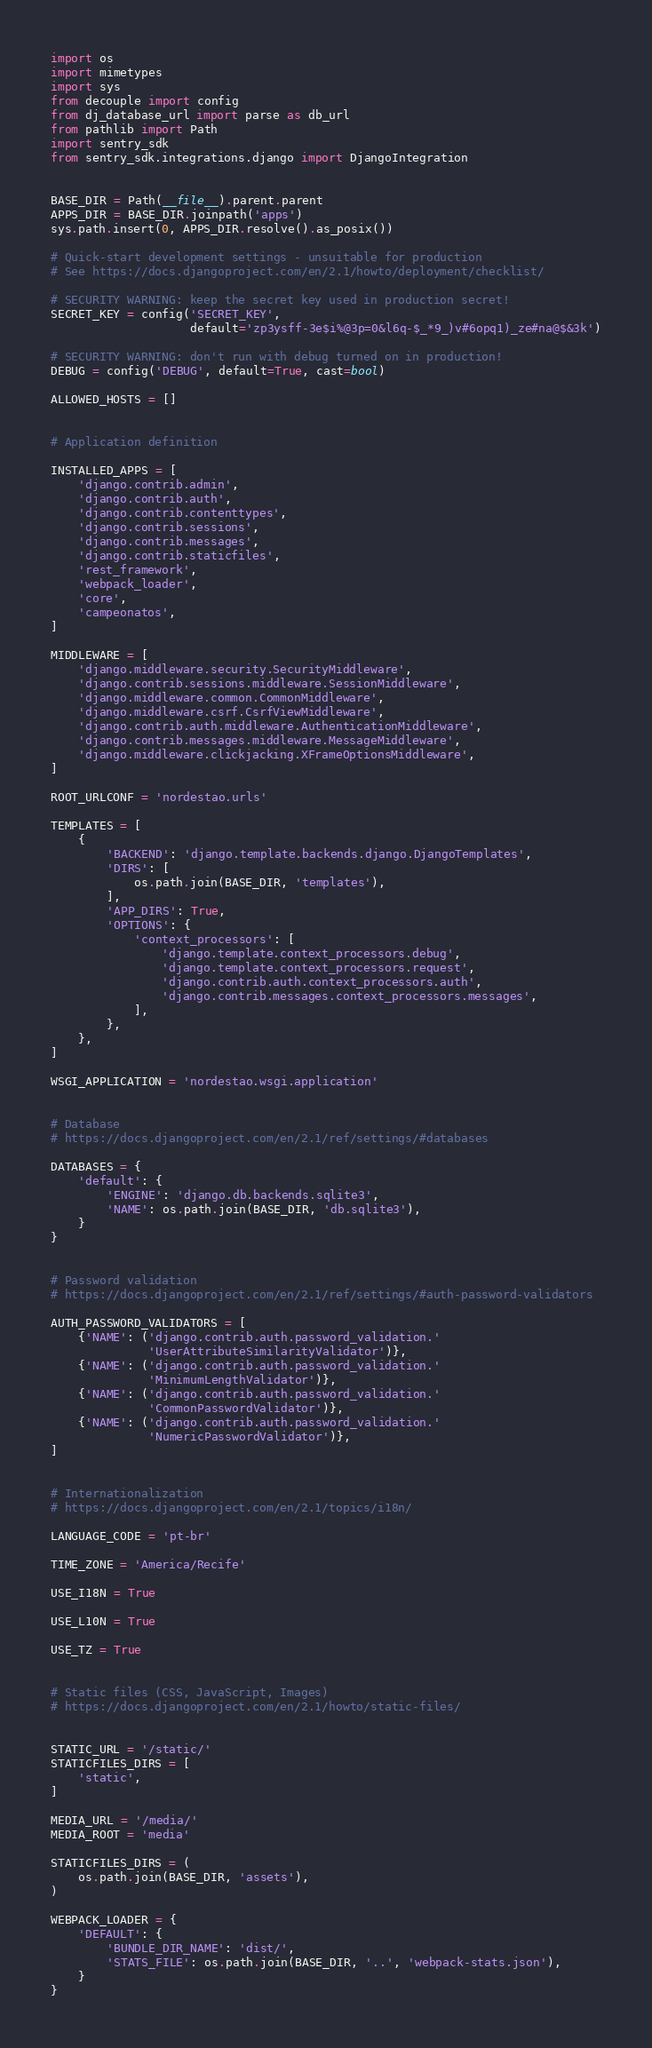<code> <loc_0><loc_0><loc_500><loc_500><_Python_>import os
import mimetypes
import sys
from decouple import config
from dj_database_url import parse as db_url
from pathlib import Path
import sentry_sdk
from sentry_sdk.integrations.django import DjangoIntegration


BASE_DIR = Path(__file__).parent.parent
APPS_DIR = BASE_DIR.joinpath('apps')
sys.path.insert(0, APPS_DIR.resolve().as_posix())

# Quick-start development settings - unsuitable for production
# See https://docs.djangoproject.com/en/2.1/howto/deployment/checklist/

# SECURITY WARNING: keep the secret key used in production secret!
SECRET_KEY = config('SECRET_KEY',
                    default='zp3ysff-3e$i%@3p=0&l6q-$_*9_)v#6opq1)_ze#na@$&3k')

# SECURITY WARNING: don't run with debug turned on in production!
DEBUG = config('DEBUG', default=True, cast=bool)

ALLOWED_HOSTS = []


# Application definition

INSTALLED_APPS = [
    'django.contrib.admin',
    'django.contrib.auth',
    'django.contrib.contenttypes',
    'django.contrib.sessions',
    'django.contrib.messages',
    'django.contrib.staticfiles',
    'rest_framework',
    'webpack_loader',
    'core',
    'campeonatos',
]

MIDDLEWARE = [
    'django.middleware.security.SecurityMiddleware',
    'django.contrib.sessions.middleware.SessionMiddleware',
    'django.middleware.common.CommonMiddleware',
    'django.middleware.csrf.CsrfViewMiddleware',
    'django.contrib.auth.middleware.AuthenticationMiddleware',
    'django.contrib.messages.middleware.MessageMiddleware',
    'django.middleware.clickjacking.XFrameOptionsMiddleware',
]

ROOT_URLCONF = 'nordestao.urls'

TEMPLATES = [
    {
        'BACKEND': 'django.template.backends.django.DjangoTemplates',
        'DIRS': [
            os.path.join(BASE_DIR, 'templates'),
        ],
        'APP_DIRS': True,
        'OPTIONS': {
            'context_processors': [
                'django.template.context_processors.debug',
                'django.template.context_processors.request',
                'django.contrib.auth.context_processors.auth',
                'django.contrib.messages.context_processors.messages',
            ],
        },
    },
]

WSGI_APPLICATION = 'nordestao.wsgi.application'


# Database
# https://docs.djangoproject.com/en/2.1/ref/settings/#databases

DATABASES = {
    'default': {
        'ENGINE': 'django.db.backends.sqlite3',
        'NAME': os.path.join(BASE_DIR, 'db.sqlite3'),
    }
}


# Password validation
# https://docs.djangoproject.com/en/2.1/ref/settings/#auth-password-validators

AUTH_PASSWORD_VALIDATORS = [
    {'NAME': ('django.contrib.auth.password_validation.'
              'UserAttributeSimilarityValidator')},
    {'NAME': ('django.contrib.auth.password_validation.'
              'MinimumLengthValidator')},
    {'NAME': ('django.contrib.auth.password_validation.'
              'CommonPasswordValidator')},
    {'NAME': ('django.contrib.auth.password_validation.'
              'NumericPasswordValidator')},
]


# Internationalization
# https://docs.djangoproject.com/en/2.1/topics/i18n/

LANGUAGE_CODE = 'pt-br'

TIME_ZONE = 'America/Recife'

USE_I18N = True

USE_L10N = True

USE_TZ = True


# Static files (CSS, JavaScript, Images)
# https://docs.djangoproject.com/en/2.1/howto/static-files/


STATIC_URL = '/static/'
STATICFILES_DIRS = [
    'static',
]

MEDIA_URL = '/media/'
MEDIA_ROOT = 'media'

STATICFILES_DIRS = (
    os.path.join(BASE_DIR, 'assets'),
)

WEBPACK_LOADER = {
    'DEFAULT': {
        'BUNDLE_DIR_NAME': 'dist/',
        'STATS_FILE': os.path.join(BASE_DIR, '..', 'webpack-stats.json'),
    }
}
</code> 